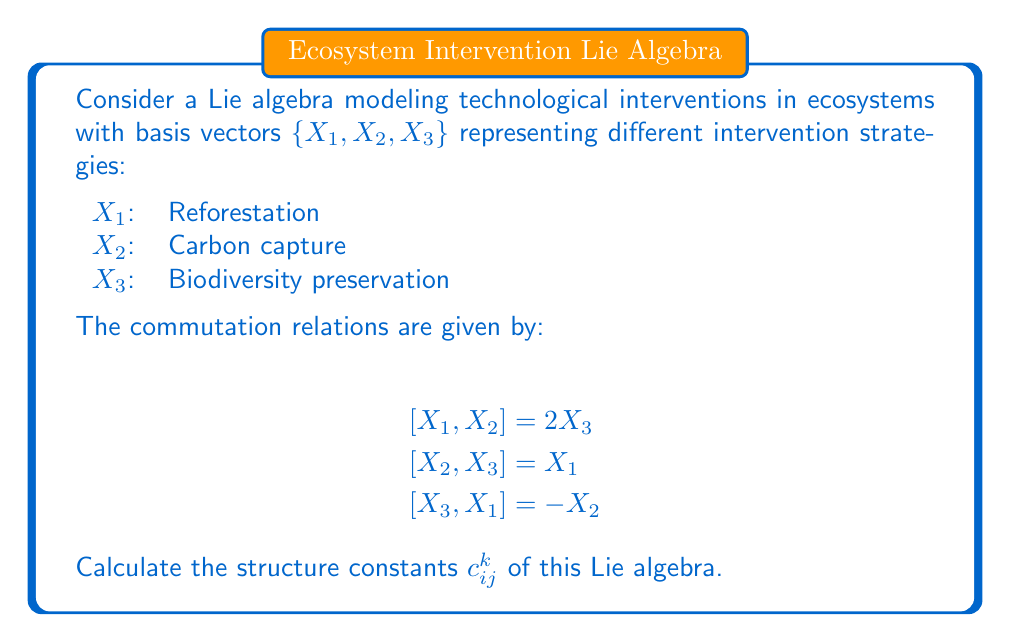What is the answer to this math problem? To calculate the structure constants $c_{ij}^k$, we use the general formula for the commutator:

$$[X_i, X_j] = \sum_{k=1}^3 c_{ij}^k X_k$$

Step 1: Analyze $[X_1, X_2] = 2X_3$
This implies $c_{12}^3 = 2$, and $c_{12}^1 = c_{12}^2 = 0$

Step 2: Analyze $[X_2, X_3] = X_1$
This implies $c_{23}^1 = 1$, and $c_{23}^2 = c_{23}^3 = 0$

Step 3: Analyze $[X_3, X_1] = -X_2$
This implies $c_{31}^2 = -1$, and $c_{31}^1 = c_{31}^3 = 0$

Step 4: Use the antisymmetry property of the commutator
$[X_i, X_j] = -[X_j, X_i]$, which means $c_{ij}^k = -c_{ji}^k$

Therefore:
$c_{21}^3 = -2$
$c_{32}^1 = -1$
$c_{13}^2 = 1$

All other structure constants are zero.

Step 5: Summarize the non-zero structure constants
$c_{12}^3 = 2$, $c_{23}^1 = 1$, $c_{31}^2 = -1$
$c_{21}^3 = -2$, $c_{32}^1 = -1$, $c_{13}^2 = 1$
Answer: $c_{12}^3 = 2$, $c_{23}^1 = 1$, $c_{31}^2 = -1$, $c_{21}^3 = -2$, $c_{32}^1 = -1$, $c_{13}^2 = 1$; all others are zero. 